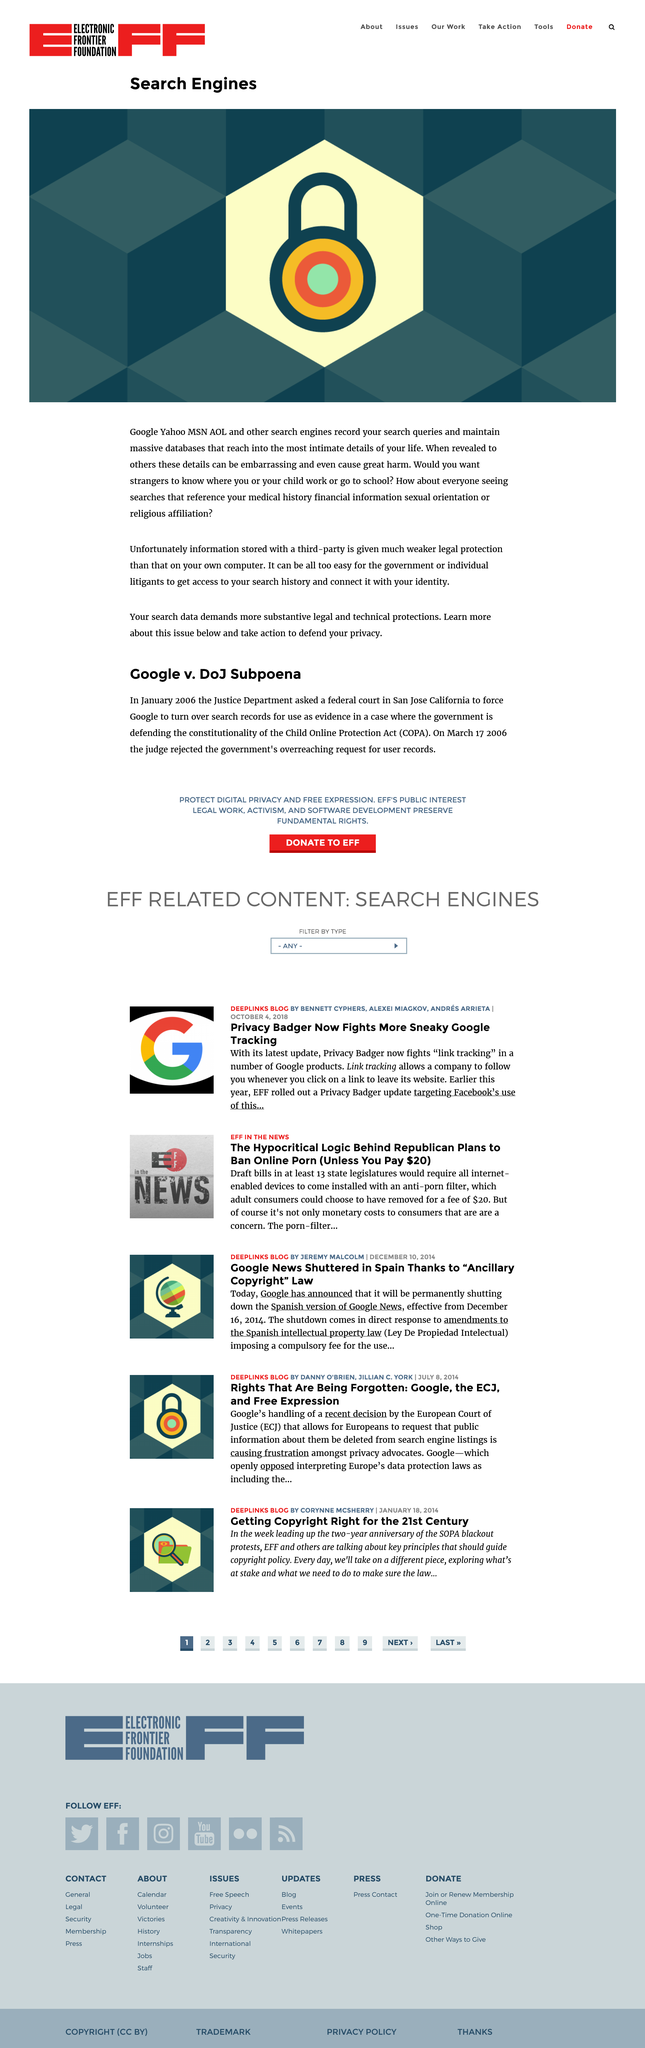Specify some key components in this picture. Google, Yahoo, MSN, and AOL are search engines that record search queries and maintain massive databases. The text reveals intimate details such as work and school location, medical history, financial information, sexual orientation, and religious affiliation. Given that search data is stored with a third-party, it receives much weaker legal protection than data stored on an individual's own computer. This makes it vulnerable to access by the government or individual litigants, who may seek to use it against the individual in legal proceedings. 